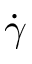Convert formula to latex. <formula><loc_0><loc_0><loc_500><loc_500>\dot { \gamma }</formula> 